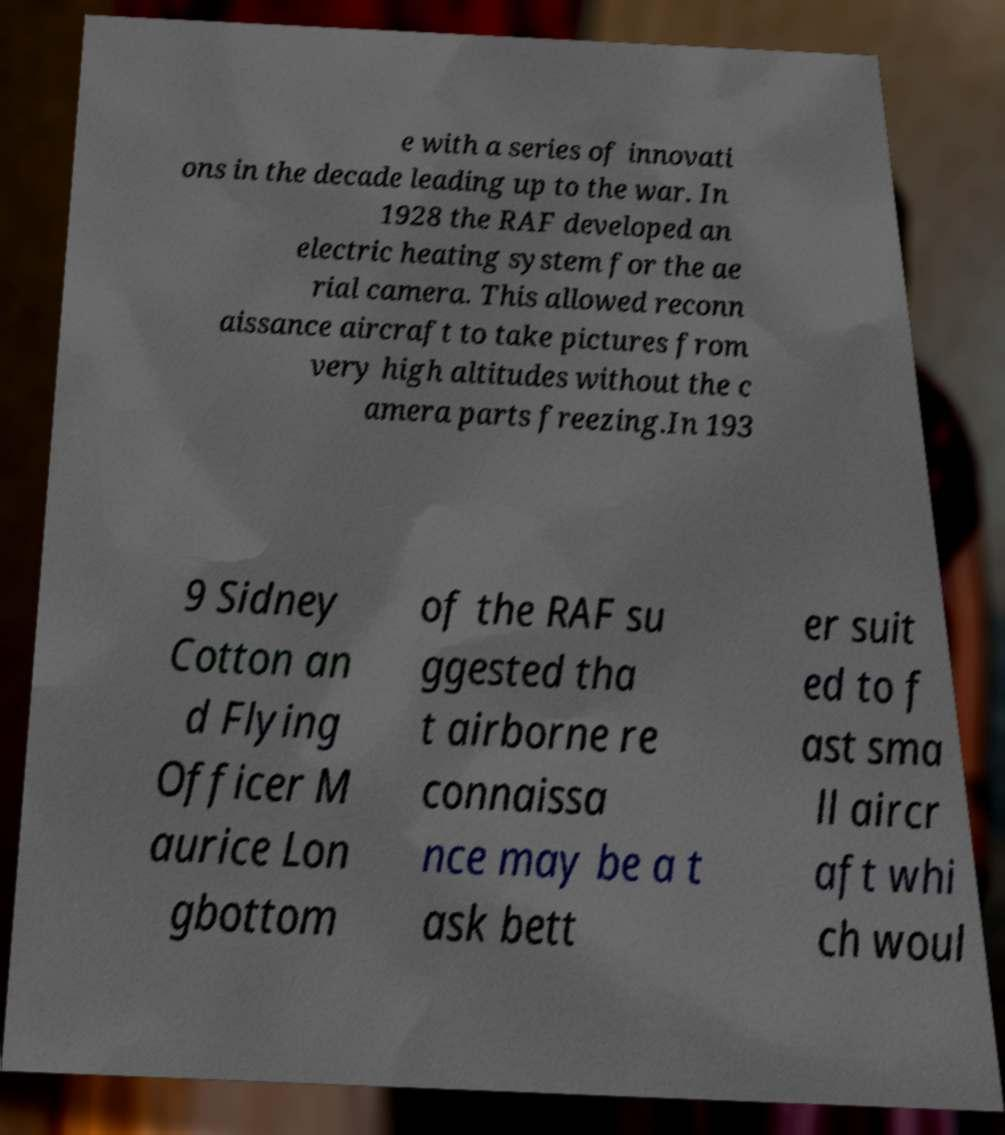I need the written content from this picture converted into text. Can you do that? e with a series of innovati ons in the decade leading up to the war. In 1928 the RAF developed an electric heating system for the ae rial camera. This allowed reconn aissance aircraft to take pictures from very high altitudes without the c amera parts freezing.In 193 9 Sidney Cotton an d Flying Officer M aurice Lon gbottom of the RAF su ggested tha t airborne re connaissa nce may be a t ask bett er suit ed to f ast sma ll aircr aft whi ch woul 